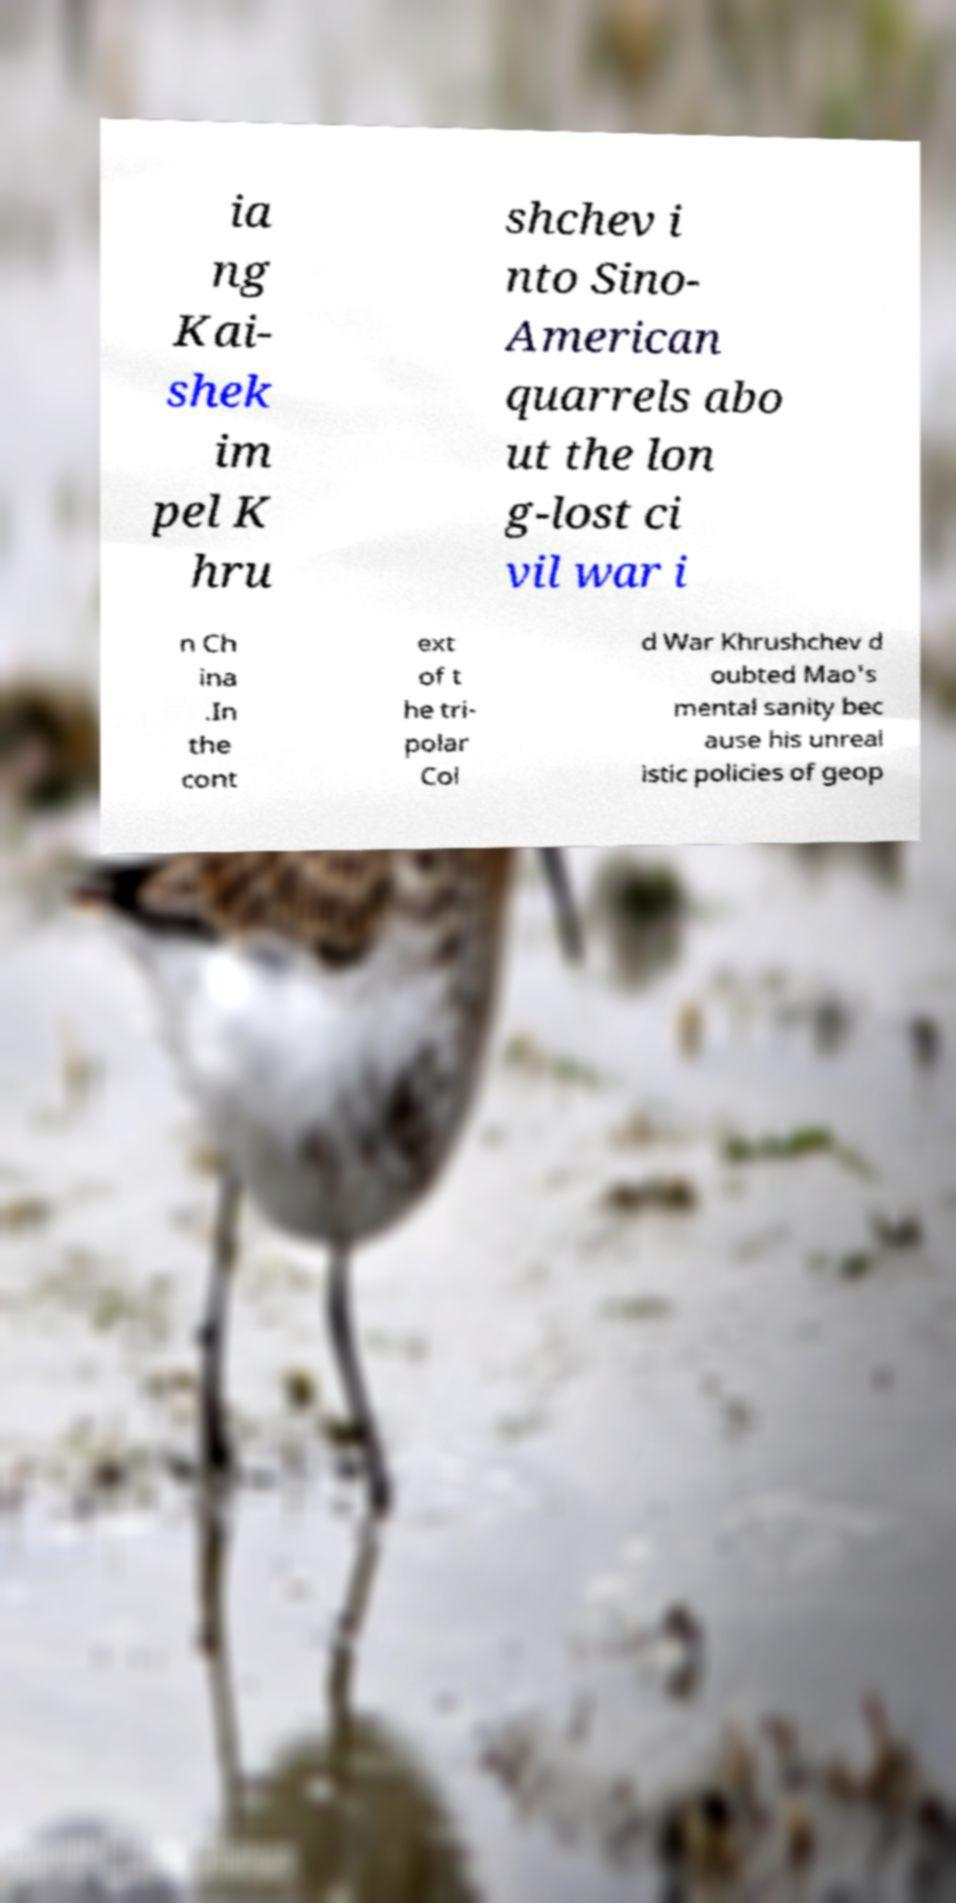Can you accurately transcribe the text from the provided image for me? ia ng Kai- shek im pel K hru shchev i nto Sino- American quarrels abo ut the lon g-lost ci vil war i n Ch ina .In the cont ext of t he tri- polar Col d War Khrushchev d oubted Mao's mental sanity bec ause his unreal istic policies of geop 